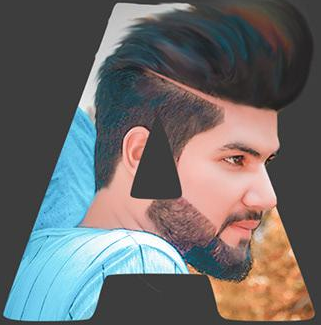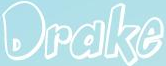What words can you see in these images in sequence, separated by a semicolon? A; Drake 